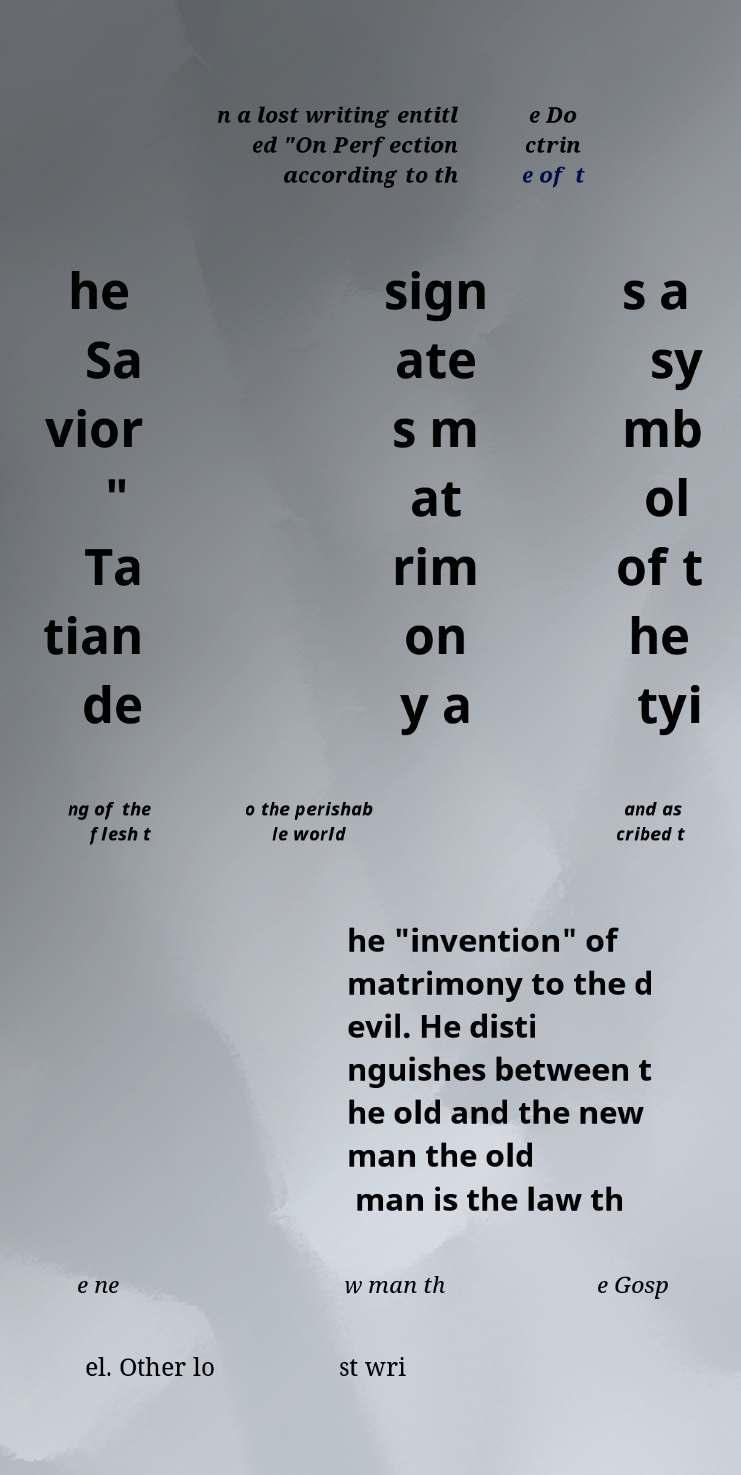Please identify and transcribe the text found in this image. n a lost writing entitl ed "On Perfection according to th e Do ctrin e of t he Sa vior " Ta tian de sign ate s m at rim on y a s a sy mb ol of t he tyi ng of the flesh t o the perishab le world and as cribed t he "invention" of matrimony to the d evil. He disti nguishes between t he old and the new man the old man is the law th e ne w man th e Gosp el. Other lo st wri 